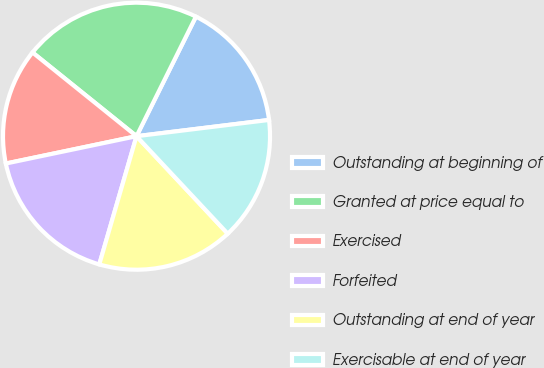<chart> <loc_0><loc_0><loc_500><loc_500><pie_chart><fcel>Outstanding at beginning of<fcel>Granted at price equal to<fcel>Exercised<fcel>Forfeited<fcel>Outstanding at end of year<fcel>Exercisable at end of year<nl><fcel>15.72%<fcel>21.55%<fcel>14.07%<fcel>17.22%<fcel>16.47%<fcel>14.97%<nl></chart> 